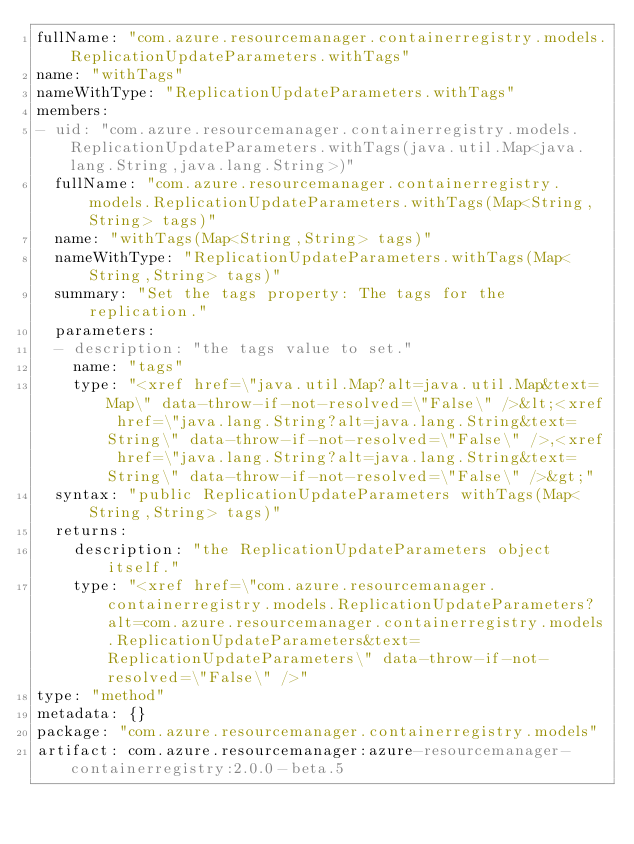Convert code to text. <code><loc_0><loc_0><loc_500><loc_500><_YAML_>fullName: "com.azure.resourcemanager.containerregistry.models.ReplicationUpdateParameters.withTags"
name: "withTags"
nameWithType: "ReplicationUpdateParameters.withTags"
members:
- uid: "com.azure.resourcemanager.containerregistry.models.ReplicationUpdateParameters.withTags(java.util.Map<java.lang.String,java.lang.String>)"
  fullName: "com.azure.resourcemanager.containerregistry.models.ReplicationUpdateParameters.withTags(Map<String,String> tags)"
  name: "withTags(Map<String,String> tags)"
  nameWithType: "ReplicationUpdateParameters.withTags(Map<String,String> tags)"
  summary: "Set the tags property: The tags for the replication."
  parameters:
  - description: "the tags value to set."
    name: "tags"
    type: "<xref href=\"java.util.Map?alt=java.util.Map&text=Map\" data-throw-if-not-resolved=\"False\" />&lt;<xref href=\"java.lang.String?alt=java.lang.String&text=String\" data-throw-if-not-resolved=\"False\" />,<xref href=\"java.lang.String?alt=java.lang.String&text=String\" data-throw-if-not-resolved=\"False\" />&gt;"
  syntax: "public ReplicationUpdateParameters withTags(Map<String,String> tags)"
  returns:
    description: "the ReplicationUpdateParameters object itself."
    type: "<xref href=\"com.azure.resourcemanager.containerregistry.models.ReplicationUpdateParameters?alt=com.azure.resourcemanager.containerregistry.models.ReplicationUpdateParameters&text=ReplicationUpdateParameters\" data-throw-if-not-resolved=\"False\" />"
type: "method"
metadata: {}
package: "com.azure.resourcemanager.containerregistry.models"
artifact: com.azure.resourcemanager:azure-resourcemanager-containerregistry:2.0.0-beta.5
</code> 